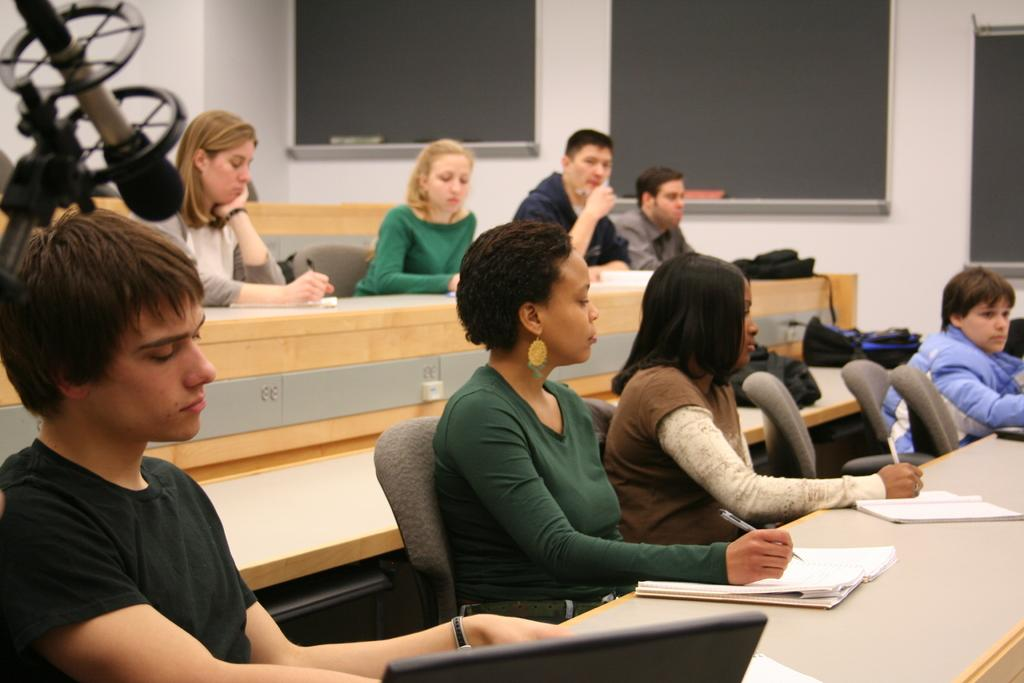What are the people in the image doing? The people in the image are sitting on chairs. What else can be seen in the image besides the people? There are tables in the image. Where is the microphone located in the image? The microphone is in the top left corner of the image. What is in the background of the image? There are blackboards in the background of the image. Can you tell me how many cows are visible in the image? There are no cows present in the image. What is the size of the ear on the person sitting on the chair? The image does not provide enough detail to determine the size of the person's ear. 